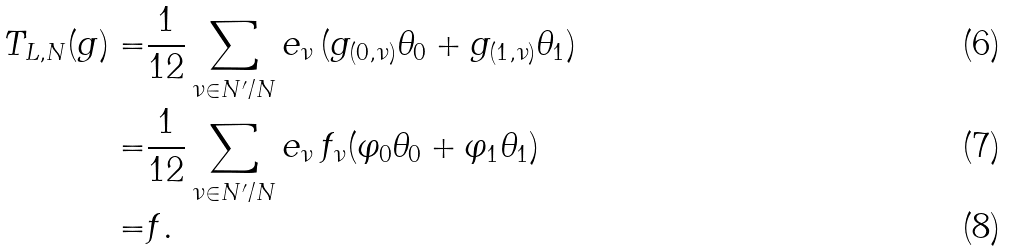Convert formula to latex. <formula><loc_0><loc_0><loc_500><loc_500>T _ { L , N } ( g ) = & \frac { 1 } { 1 2 } \sum _ { \nu \in N ^ { \prime } / N } e _ { \nu } \, ( g _ { ( 0 , \nu ) } \theta _ { 0 } + g _ { ( 1 , \nu ) } \theta _ { 1 } ) \\ = & \frac { 1 } { 1 2 } \sum _ { \nu \in N ^ { \prime } / N } e _ { \nu } \, f _ { \nu } ( \varphi _ { 0 } \theta _ { 0 } + \varphi _ { 1 } \theta _ { 1 } ) \\ = & f .</formula> 